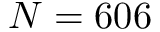<formula> <loc_0><loc_0><loc_500><loc_500>N = 6 0 6</formula> 